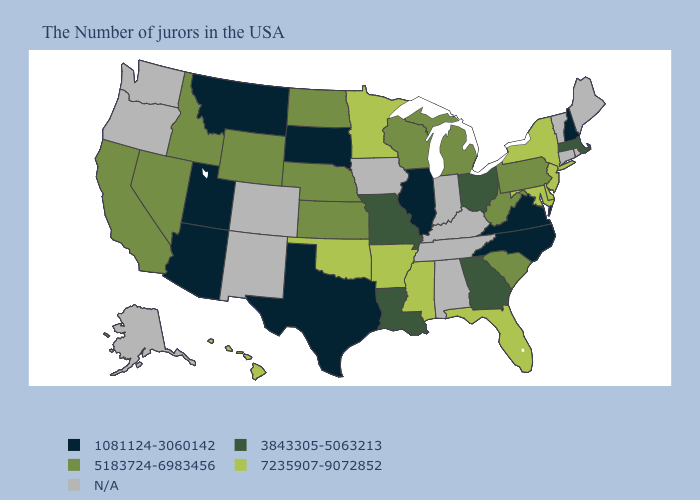What is the highest value in the USA?
Concise answer only. 7235907-9072852. Name the states that have a value in the range N/A?
Short answer required. Maine, Rhode Island, Vermont, Connecticut, Kentucky, Indiana, Alabama, Tennessee, Iowa, Colorado, New Mexico, Washington, Oregon, Alaska. Among the states that border New Jersey , does Pennsylvania have the highest value?
Keep it brief. No. Which states have the lowest value in the USA?
Keep it brief. New Hampshire, Virginia, North Carolina, Illinois, Texas, South Dakota, Utah, Montana, Arizona. Among the states that border Texas , which have the highest value?
Keep it brief. Arkansas, Oklahoma. What is the value of Maryland?
Quick response, please. 7235907-9072852. What is the value of New Mexico?
Write a very short answer. N/A. Does California have the highest value in the West?
Concise answer only. No. Does the map have missing data?
Answer briefly. Yes. Does Hawaii have the lowest value in the USA?
Give a very brief answer. No. Name the states that have a value in the range 5183724-6983456?
Short answer required. Pennsylvania, South Carolina, West Virginia, Michigan, Wisconsin, Kansas, Nebraska, North Dakota, Wyoming, Idaho, Nevada, California. What is the value of Illinois?
Give a very brief answer. 1081124-3060142. Name the states that have a value in the range N/A?
Write a very short answer. Maine, Rhode Island, Vermont, Connecticut, Kentucky, Indiana, Alabama, Tennessee, Iowa, Colorado, New Mexico, Washington, Oregon, Alaska. 